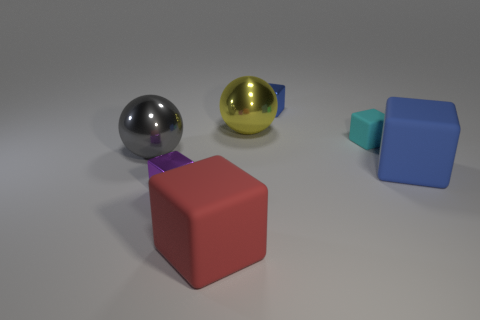Subtract all gray cylinders. How many blue cubes are left? 2 Add 1 blue rubber cubes. How many objects exist? 8 Subtract all small purple metal blocks. How many blocks are left? 4 Subtract 3 cubes. How many cubes are left? 2 Subtract all blue cubes. How many cubes are left? 3 Subtract all cyan blocks. Subtract all brown cylinders. How many blocks are left? 4 Subtract all balls. How many objects are left? 5 Subtract all large things. Subtract all tiny objects. How many objects are left? 0 Add 6 small blue objects. How many small blue objects are left? 7 Add 2 cylinders. How many cylinders exist? 2 